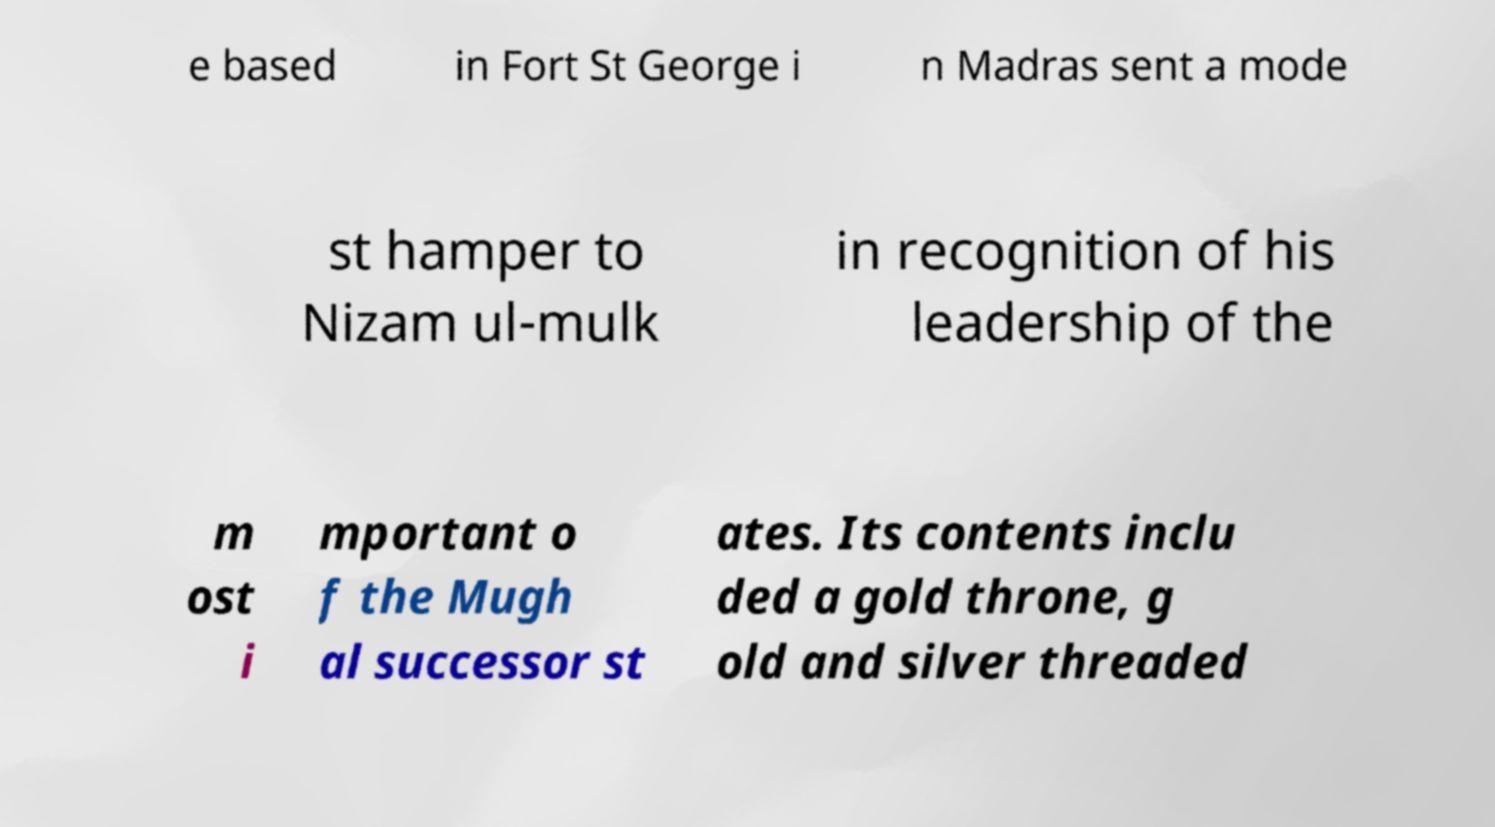There's text embedded in this image that I need extracted. Can you transcribe it verbatim? e based in Fort St George i n Madras sent a mode st hamper to Nizam ul-mulk in recognition of his leadership of the m ost i mportant o f the Mugh al successor st ates. Its contents inclu ded a gold throne, g old and silver threaded 